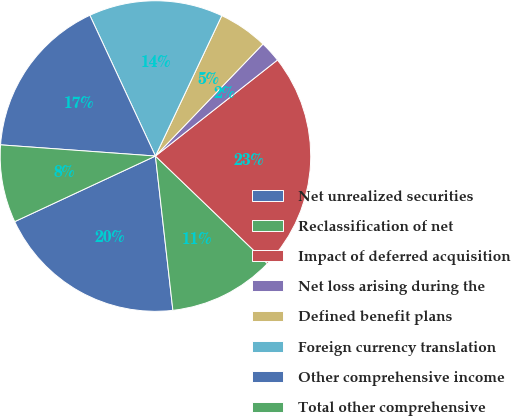Convert chart to OTSL. <chart><loc_0><loc_0><loc_500><loc_500><pie_chart><fcel>Net unrealized securities<fcel>Reclassification of net<fcel>Impact of deferred acquisition<fcel>Net loss arising during the<fcel>Defined benefit plans<fcel>Foreign currency translation<fcel>Other comprehensive income<fcel>Total other comprehensive<nl><fcel>19.85%<fcel>11.03%<fcel>22.79%<fcel>2.21%<fcel>5.15%<fcel>13.97%<fcel>16.91%<fcel>8.09%<nl></chart> 